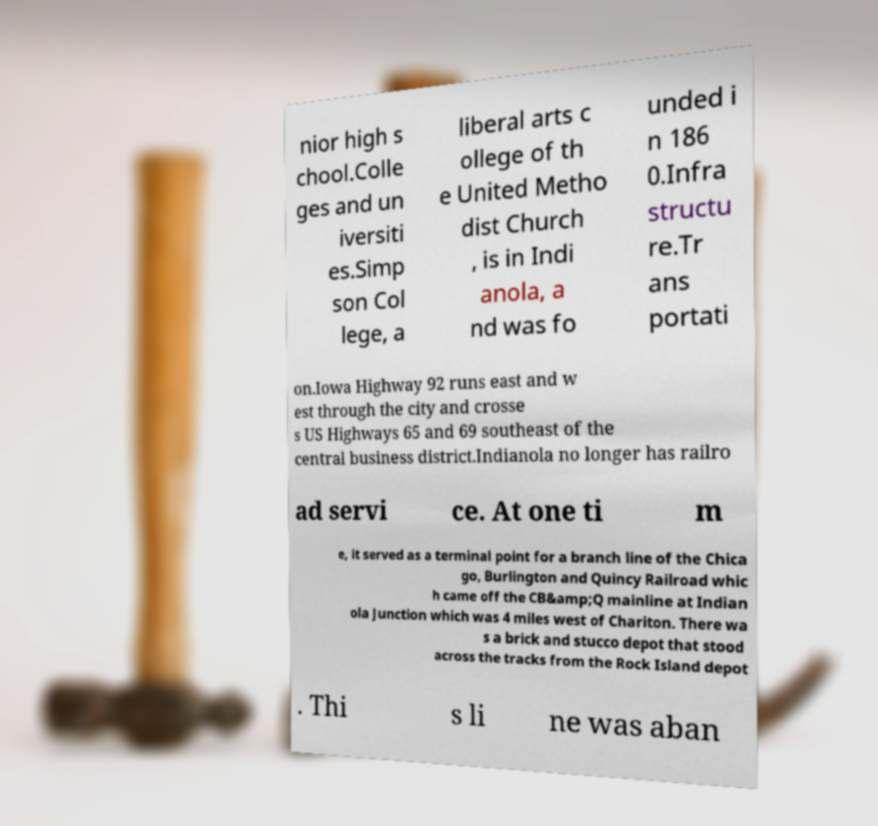I need the written content from this picture converted into text. Can you do that? nior high s chool.Colle ges and un iversiti es.Simp son Col lege, a liberal arts c ollege of th e United Metho dist Church , is in Indi anola, a nd was fo unded i n 186 0.Infra structu re.Tr ans portati on.Iowa Highway 92 runs east and w est through the city and crosse s US Highways 65 and 69 southeast of the central business district.Indianola no longer has railro ad servi ce. At one ti m e, it served as a terminal point for a branch line of the Chica go, Burlington and Quincy Railroad whic h came off the CB&amp;Q mainline at Indian ola Junction which was 4 miles west of Chariton. There wa s a brick and stucco depot that stood across the tracks from the Rock Island depot . Thi s li ne was aban 